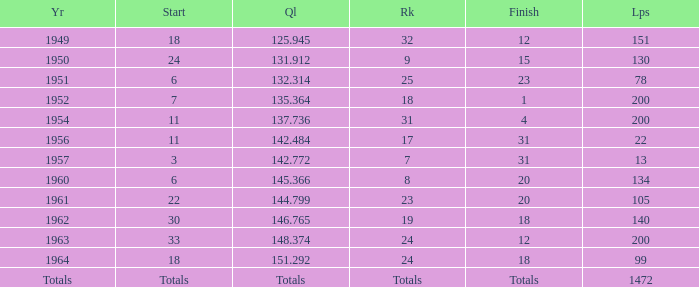Name the rank for laps less than 130 and year of 1951 25.0. 